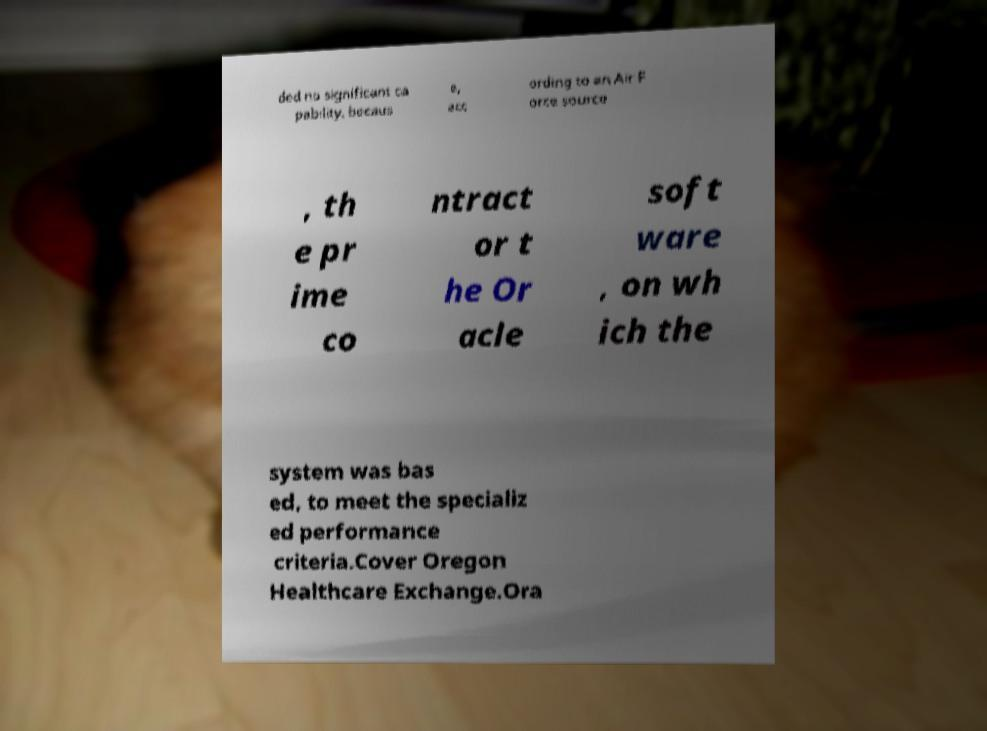There's text embedded in this image that I need extracted. Can you transcribe it verbatim? ded no significant ca pability, becaus e, acc ording to an Air F orce source , th e pr ime co ntract or t he Or acle soft ware , on wh ich the system was bas ed, to meet the specializ ed performance criteria.Cover Oregon Healthcare Exchange.Ora 